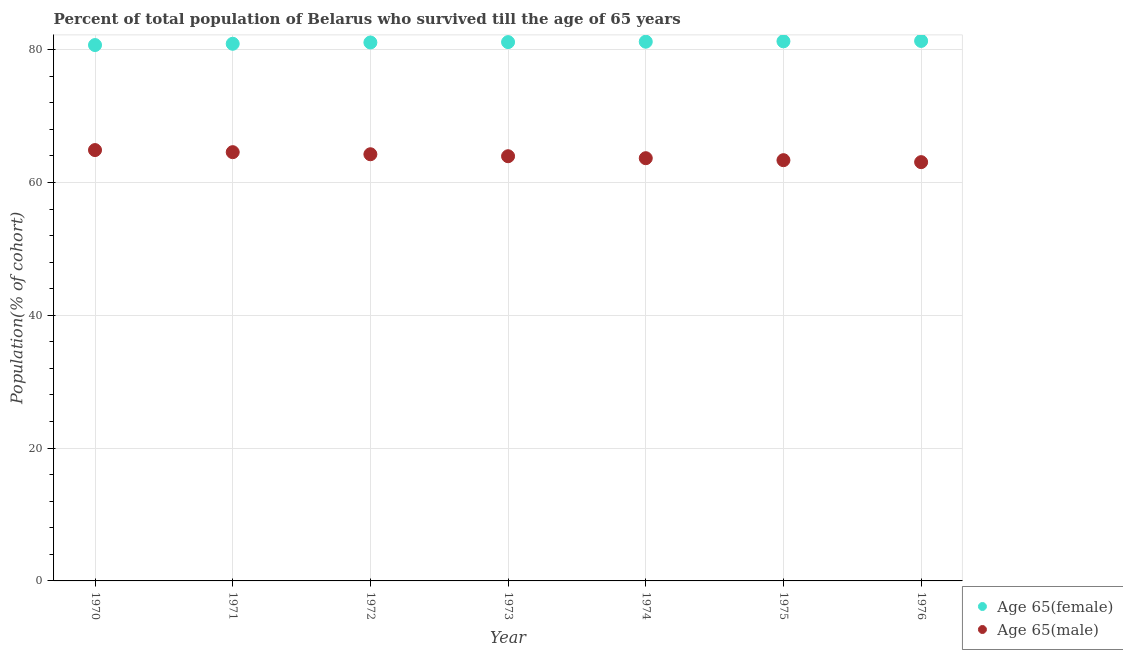What is the percentage of female population who survived till age of 65 in 1974?
Your response must be concise. 81.19. Across all years, what is the maximum percentage of female population who survived till age of 65?
Give a very brief answer. 81.31. Across all years, what is the minimum percentage of male population who survived till age of 65?
Keep it short and to the point. 63.06. In which year was the percentage of male population who survived till age of 65 minimum?
Make the answer very short. 1976. What is the total percentage of female population who survived till age of 65 in the graph?
Provide a succinct answer. 567.54. What is the difference between the percentage of female population who survived till age of 65 in 1974 and that in 1976?
Keep it short and to the point. -0.12. What is the difference between the percentage of female population who survived till age of 65 in 1972 and the percentage of male population who survived till age of 65 in 1970?
Ensure brevity in your answer.  16.2. What is the average percentage of male population who survived till age of 65 per year?
Offer a terse response. 63.96. In the year 1976, what is the difference between the percentage of female population who survived till age of 65 and percentage of male population who survived till age of 65?
Offer a terse response. 18.25. In how many years, is the percentage of male population who survived till age of 65 greater than 40 %?
Offer a very short reply. 7. What is the ratio of the percentage of male population who survived till age of 65 in 1972 to that in 1975?
Make the answer very short. 1.01. Is the difference between the percentage of male population who survived till age of 65 in 1972 and 1976 greater than the difference between the percentage of female population who survived till age of 65 in 1972 and 1976?
Offer a very short reply. Yes. What is the difference between the highest and the second highest percentage of female population who survived till age of 65?
Ensure brevity in your answer.  0.06. What is the difference between the highest and the lowest percentage of male population who survived till age of 65?
Give a very brief answer. 1.82. Does the percentage of female population who survived till age of 65 monotonically increase over the years?
Provide a short and direct response. Yes. Is the percentage of male population who survived till age of 65 strictly greater than the percentage of female population who survived till age of 65 over the years?
Provide a short and direct response. No. How many dotlines are there?
Offer a very short reply. 2. How many years are there in the graph?
Your answer should be very brief. 7. What is the difference between two consecutive major ticks on the Y-axis?
Your answer should be compact. 20. Are the values on the major ticks of Y-axis written in scientific E-notation?
Ensure brevity in your answer.  No. Does the graph contain any zero values?
Your answer should be compact. No. How many legend labels are there?
Keep it short and to the point. 2. How are the legend labels stacked?
Keep it short and to the point. Vertical. What is the title of the graph?
Provide a succinct answer. Percent of total population of Belarus who survived till the age of 65 years. Does "DAC donors" appear as one of the legend labels in the graph?
Offer a very short reply. No. What is the label or title of the Y-axis?
Offer a very short reply. Population(% of cohort). What is the Population(% of cohort) in Age 65(female) in 1970?
Make the answer very short. 80.69. What is the Population(% of cohort) of Age 65(male) in 1970?
Your answer should be very brief. 64.88. What is the Population(% of cohort) of Age 65(female) in 1971?
Offer a terse response. 80.88. What is the Population(% of cohort) of Age 65(male) in 1971?
Your response must be concise. 64.56. What is the Population(% of cohort) in Age 65(female) in 1972?
Ensure brevity in your answer.  81.08. What is the Population(% of cohort) of Age 65(male) in 1972?
Provide a succinct answer. 64.25. What is the Population(% of cohort) of Age 65(female) in 1973?
Offer a very short reply. 81.13. What is the Population(% of cohort) in Age 65(male) in 1973?
Keep it short and to the point. 63.95. What is the Population(% of cohort) of Age 65(female) in 1974?
Your answer should be compact. 81.19. What is the Population(% of cohort) in Age 65(male) in 1974?
Make the answer very short. 63.65. What is the Population(% of cohort) in Age 65(female) in 1975?
Keep it short and to the point. 81.25. What is the Population(% of cohort) of Age 65(male) in 1975?
Your answer should be compact. 63.36. What is the Population(% of cohort) in Age 65(female) in 1976?
Offer a very short reply. 81.31. What is the Population(% of cohort) in Age 65(male) in 1976?
Provide a succinct answer. 63.06. Across all years, what is the maximum Population(% of cohort) in Age 65(female)?
Provide a succinct answer. 81.31. Across all years, what is the maximum Population(% of cohort) in Age 65(male)?
Make the answer very short. 64.88. Across all years, what is the minimum Population(% of cohort) of Age 65(female)?
Offer a very short reply. 80.69. Across all years, what is the minimum Population(% of cohort) in Age 65(male)?
Give a very brief answer. 63.06. What is the total Population(% of cohort) in Age 65(female) in the graph?
Your answer should be compact. 567.54. What is the total Population(% of cohort) of Age 65(male) in the graph?
Provide a succinct answer. 447.71. What is the difference between the Population(% of cohort) in Age 65(female) in 1970 and that in 1971?
Your answer should be very brief. -0.19. What is the difference between the Population(% of cohort) of Age 65(male) in 1970 and that in 1971?
Ensure brevity in your answer.  0.31. What is the difference between the Population(% of cohort) of Age 65(female) in 1970 and that in 1972?
Offer a very short reply. -0.39. What is the difference between the Population(% of cohort) in Age 65(male) in 1970 and that in 1972?
Your response must be concise. 0.63. What is the difference between the Population(% of cohort) in Age 65(female) in 1970 and that in 1973?
Ensure brevity in your answer.  -0.44. What is the difference between the Population(% of cohort) of Age 65(male) in 1970 and that in 1973?
Provide a short and direct response. 0.93. What is the difference between the Population(% of cohort) in Age 65(female) in 1970 and that in 1974?
Provide a succinct answer. -0.5. What is the difference between the Population(% of cohort) in Age 65(male) in 1970 and that in 1974?
Your response must be concise. 1.22. What is the difference between the Population(% of cohort) in Age 65(female) in 1970 and that in 1975?
Ensure brevity in your answer.  -0.56. What is the difference between the Population(% of cohort) of Age 65(male) in 1970 and that in 1975?
Provide a succinct answer. 1.52. What is the difference between the Population(% of cohort) in Age 65(female) in 1970 and that in 1976?
Your response must be concise. -0.62. What is the difference between the Population(% of cohort) of Age 65(male) in 1970 and that in 1976?
Offer a very short reply. 1.82. What is the difference between the Population(% of cohort) of Age 65(female) in 1971 and that in 1972?
Your answer should be compact. -0.19. What is the difference between the Population(% of cohort) of Age 65(male) in 1971 and that in 1972?
Your answer should be very brief. 0.31. What is the difference between the Population(% of cohort) in Age 65(female) in 1971 and that in 1973?
Provide a short and direct response. -0.25. What is the difference between the Population(% of cohort) in Age 65(male) in 1971 and that in 1973?
Provide a short and direct response. 0.61. What is the difference between the Population(% of cohort) of Age 65(female) in 1971 and that in 1974?
Your response must be concise. -0.31. What is the difference between the Population(% of cohort) of Age 65(male) in 1971 and that in 1974?
Your answer should be very brief. 0.91. What is the difference between the Population(% of cohort) of Age 65(female) in 1971 and that in 1975?
Your answer should be compact. -0.37. What is the difference between the Population(% of cohort) in Age 65(male) in 1971 and that in 1975?
Keep it short and to the point. 1.21. What is the difference between the Population(% of cohort) of Age 65(female) in 1971 and that in 1976?
Make the answer very short. -0.43. What is the difference between the Population(% of cohort) of Age 65(male) in 1971 and that in 1976?
Offer a terse response. 1.5. What is the difference between the Population(% of cohort) in Age 65(female) in 1972 and that in 1973?
Offer a very short reply. -0.06. What is the difference between the Population(% of cohort) in Age 65(male) in 1972 and that in 1973?
Your response must be concise. 0.3. What is the difference between the Population(% of cohort) of Age 65(female) in 1972 and that in 1974?
Your answer should be very brief. -0.12. What is the difference between the Population(% of cohort) of Age 65(male) in 1972 and that in 1974?
Make the answer very short. 0.59. What is the difference between the Population(% of cohort) of Age 65(female) in 1972 and that in 1975?
Your response must be concise. -0.18. What is the difference between the Population(% of cohort) of Age 65(male) in 1972 and that in 1975?
Your response must be concise. 0.89. What is the difference between the Population(% of cohort) of Age 65(female) in 1972 and that in 1976?
Your response must be concise. -0.23. What is the difference between the Population(% of cohort) in Age 65(male) in 1972 and that in 1976?
Make the answer very short. 1.19. What is the difference between the Population(% of cohort) in Age 65(female) in 1973 and that in 1974?
Your response must be concise. -0.06. What is the difference between the Population(% of cohort) of Age 65(male) in 1973 and that in 1974?
Make the answer very short. 0.3. What is the difference between the Population(% of cohort) in Age 65(female) in 1973 and that in 1975?
Your answer should be very brief. -0.12. What is the difference between the Population(% of cohort) in Age 65(male) in 1973 and that in 1975?
Provide a short and direct response. 0.59. What is the difference between the Population(% of cohort) in Age 65(female) in 1973 and that in 1976?
Provide a succinct answer. -0.18. What is the difference between the Population(% of cohort) in Age 65(male) in 1973 and that in 1976?
Offer a terse response. 0.89. What is the difference between the Population(% of cohort) in Age 65(female) in 1974 and that in 1975?
Your answer should be very brief. -0.06. What is the difference between the Population(% of cohort) of Age 65(male) in 1974 and that in 1975?
Offer a terse response. 0.3. What is the difference between the Population(% of cohort) in Age 65(female) in 1974 and that in 1976?
Provide a succinct answer. -0.12. What is the difference between the Population(% of cohort) of Age 65(male) in 1974 and that in 1976?
Your answer should be compact. 0.59. What is the difference between the Population(% of cohort) in Age 65(female) in 1975 and that in 1976?
Offer a very short reply. -0.06. What is the difference between the Population(% of cohort) in Age 65(male) in 1975 and that in 1976?
Offer a very short reply. 0.3. What is the difference between the Population(% of cohort) of Age 65(female) in 1970 and the Population(% of cohort) of Age 65(male) in 1971?
Give a very brief answer. 16.13. What is the difference between the Population(% of cohort) in Age 65(female) in 1970 and the Population(% of cohort) in Age 65(male) in 1972?
Provide a succinct answer. 16.44. What is the difference between the Population(% of cohort) of Age 65(female) in 1970 and the Population(% of cohort) of Age 65(male) in 1973?
Make the answer very short. 16.74. What is the difference between the Population(% of cohort) of Age 65(female) in 1970 and the Population(% of cohort) of Age 65(male) in 1974?
Give a very brief answer. 17.04. What is the difference between the Population(% of cohort) in Age 65(female) in 1970 and the Population(% of cohort) in Age 65(male) in 1975?
Keep it short and to the point. 17.33. What is the difference between the Population(% of cohort) in Age 65(female) in 1970 and the Population(% of cohort) in Age 65(male) in 1976?
Your response must be concise. 17.63. What is the difference between the Population(% of cohort) of Age 65(female) in 1971 and the Population(% of cohort) of Age 65(male) in 1972?
Provide a succinct answer. 16.64. What is the difference between the Population(% of cohort) of Age 65(female) in 1971 and the Population(% of cohort) of Age 65(male) in 1973?
Your answer should be compact. 16.93. What is the difference between the Population(% of cohort) of Age 65(female) in 1971 and the Population(% of cohort) of Age 65(male) in 1974?
Your answer should be compact. 17.23. What is the difference between the Population(% of cohort) of Age 65(female) in 1971 and the Population(% of cohort) of Age 65(male) in 1975?
Ensure brevity in your answer.  17.53. What is the difference between the Population(% of cohort) in Age 65(female) in 1971 and the Population(% of cohort) in Age 65(male) in 1976?
Offer a very short reply. 17.82. What is the difference between the Population(% of cohort) in Age 65(female) in 1972 and the Population(% of cohort) in Age 65(male) in 1973?
Offer a very short reply. 17.13. What is the difference between the Population(% of cohort) in Age 65(female) in 1972 and the Population(% of cohort) in Age 65(male) in 1974?
Ensure brevity in your answer.  17.42. What is the difference between the Population(% of cohort) in Age 65(female) in 1972 and the Population(% of cohort) in Age 65(male) in 1975?
Provide a succinct answer. 17.72. What is the difference between the Population(% of cohort) of Age 65(female) in 1972 and the Population(% of cohort) of Age 65(male) in 1976?
Keep it short and to the point. 18.02. What is the difference between the Population(% of cohort) of Age 65(female) in 1973 and the Population(% of cohort) of Age 65(male) in 1974?
Provide a succinct answer. 17.48. What is the difference between the Population(% of cohort) of Age 65(female) in 1973 and the Population(% of cohort) of Age 65(male) in 1975?
Give a very brief answer. 17.78. What is the difference between the Population(% of cohort) in Age 65(female) in 1973 and the Population(% of cohort) in Age 65(male) in 1976?
Your answer should be compact. 18.08. What is the difference between the Population(% of cohort) of Age 65(female) in 1974 and the Population(% of cohort) of Age 65(male) in 1975?
Give a very brief answer. 17.84. What is the difference between the Population(% of cohort) in Age 65(female) in 1974 and the Population(% of cohort) in Age 65(male) in 1976?
Make the answer very short. 18.13. What is the difference between the Population(% of cohort) of Age 65(female) in 1975 and the Population(% of cohort) of Age 65(male) in 1976?
Ensure brevity in your answer.  18.19. What is the average Population(% of cohort) of Age 65(female) per year?
Give a very brief answer. 81.08. What is the average Population(% of cohort) in Age 65(male) per year?
Your answer should be very brief. 63.96. In the year 1970, what is the difference between the Population(% of cohort) of Age 65(female) and Population(% of cohort) of Age 65(male)?
Your answer should be very brief. 15.81. In the year 1971, what is the difference between the Population(% of cohort) in Age 65(female) and Population(% of cohort) in Age 65(male)?
Offer a very short reply. 16.32. In the year 1972, what is the difference between the Population(% of cohort) of Age 65(female) and Population(% of cohort) of Age 65(male)?
Make the answer very short. 16.83. In the year 1973, what is the difference between the Population(% of cohort) of Age 65(female) and Population(% of cohort) of Age 65(male)?
Offer a very short reply. 17.18. In the year 1974, what is the difference between the Population(% of cohort) in Age 65(female) and Population(% of cohort) in Age 65(male)?
Provide a short and direct response. 17.54. In the year 1975, what is the difference between the Population(% of cohort) of Age 65(female) and Population(% of cohort) of Age 65(male)?
Your answer should be very brief. 17.9. In the year 1976, what is the difference between the Population(% of cohort) in Age 65(female) and Population(% of cohort) in Age 65(male)?
Offer a very short reply. 18.25. What is the ratio of the Population(% of cohort) in Age 65(female) in 1970 to that in 1972?
Ensure brevity in your answer.  1. What is the ratio of the Population(% of cohort) in Age 65(male) in 1970 to that in 1972?
Make the answer very short. 1.01. What is the ratio of the Population(% of cohort) in Age 65(female) in 1970 to that in 1973?
Your response must be concise. 0.99. What is the ratio of the Population(% of cohort) in Age 65(male) in 1970 to that in 1973?
Keep it short and to the point. 1.01. What is the ratio of the Population(% of cohort) of Age 65(female) in 1970 to that in 1974?
Offer a terse response. 0.99. What is the ratio of the Population(% of cohort) in Age 65(male) in 1970 to that in 1974?
Provide a succinct answer. 1.02. What is the ratio of the Population(% of cohort) of Age 65(female) in 1970 to that in 1975?
Ensure brevity in your answer.  0.99. What is the ratio of the Population(% of cohort) in Age 65(male) in 1970 to that in 1975?
Your answer should be very brief. 1.02. What is the ratio of the Population(% of cohort) of Age 65(female) in 1970 to that in 1976?
Provide a succinct answer. 0.99. What is the ratio of the Population(% of cohort) in Age 65(male) in 1970 to that in 1976?
Your answer should be compact. 1.03. What is the ratio of the Population(% of cohort) in Age 65(male) in 1971 to that in 1973?
Provide a succinct answer. 1.01. What is the ratio of the Population(% of cohort) in Age 65(female) in 1971 to that in 1974?
Give a very brief answer. 1. What is the ratio of the Population(% of cohort) in Age 65(male) in 1971 to that in 1974?
Provide a short and direct response. 1.01. What is the ratio of the Population(% of cohort) of Age 65(female) in 1971 to that in 1975?
Your answer should be compact. 1. What is the ratio of the Population(% of cohort) in Age 65(male) in 1971 to that in 1975?
Give a very brief answer. 1.02. What is the ratio of the Population(% of cohort) of Age 65(female) in 1971 to that in 1976?
Provide a succinct answer. 0.99. What is the ratio of the Population(% of cohort) in Age 65(male) in 1971 to that in 1976?
Provide a short and direct response. 1.02. What is the ratio of the Population(% of cohort) of Age 65(female) in 1972 to that in 1973?
Ensure brevity in your answer.  1. What is the ratio of the Population(% of cohort) in Age 65(male) in 1972 to that in 1973?
Your answer should be compact. 1. What is the ratio of the Population(% of cohort) of Age 65(male) in 1972 to that in 1974?
Ensure brevity in your answer.  1.01. What is the ratio of the Population(% of cohort) in Age 65(female) in 1972 to that in 1975?
Give a very brief answer. 1. What is the ratio of the Population(% of cohort) in Age 65(male) in 1972 to that in 1975?
Your response must be concise. 1.01. What is the ratio of the Population(% of cohort) of Age 65(female) in 1972 to that in 1976?
Provide a succinct answer. 1. What is the ratio of the Population(% of cohort) of Age 65(male) in 1972 to that in 1976?
Make the answer very short. 1.02. What is the ratio of the Population(% of cohort) in Age 65(female) in 1973 to that in 1974?
Ensure brevity in your answer.  1. What is the ratio of the Population(% of cohort) in Age 65(male) in 1973 to that in 1975?
Ensure brevity in your answer.  1.01. What is the ratio of the Population(% of cohort) in Age 65(female) in 1973 to that in 1976?
Offer a very short reply. 1. What is the ratio of the Population(% of cohort) in Age 65(male) in 1973 to that in 1976?
Make the answer very short. 1.01. What is the ratio of the Population(% of cohort) in Age 65(female) in 1974 to that in 1976?
Offer a terse response. 1. What is the ratio of the Population(% of cohort) of Age 65(male) in 1974 to that in 1976?
Make the answer very short. 1.01. What is the ratio of the Population(% of cohort) of Age 65(male) in 1975 to that in 1976?
Provide a short and direct response. 1. What is the difference between the highest and the second highest Population(% of cohort) in Age 65(female)?
Your answer should be compact. 0.06. What is the difference between the highest and the second highest Population(% of cohort) of Age 65(male)?
Your response must be concise. 0.31. What is the difference between the highest and the lowest Population(% of cohort) in Age 65(female)?
Your response must be concise. 0.62. What is the difference between the highest and the lowest Population(% of cohort) in Age 65(male)?
Offer a terse response. 1.82. 